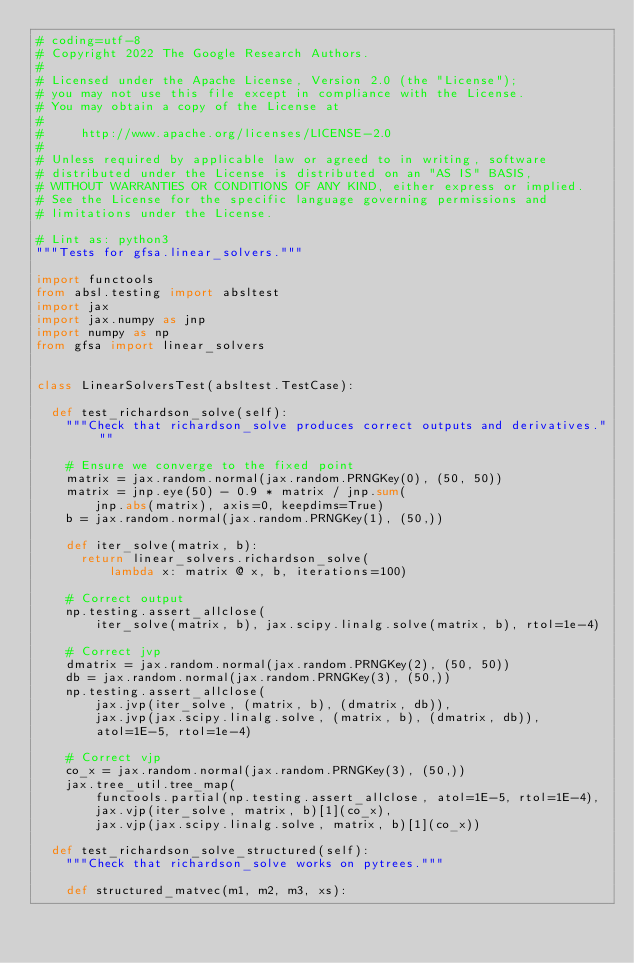Convert code to text. <code><loc_0><loc_0><loc_500><loc_500><_Python_># coding=utf-8
# Copyright 2022 The Google Research Authors.
#
# Licensed under the Apache License, Version 2.0 (the "License");
# you may not use this file except in compliance with the License.
# You may obtain a copy of the License at
#
#     http://www.apache.org/licenses/LICENSE-2.0
#
# Unless required by applicable law or agreed to in writing, software
# distributed under the License is distributed on an "AS IS" BASIS,
# WITHOUT WARRANTIES OR CONDITIONS OF ANY KIND, either express or implied.
# See the License for the specific language governing permissions and
# limitations under the License.

# Lint as: python3
"""Tests for gfsa.linear_solvers."""

import functools
from absl.testing import absltest
import jax
import jax.numpy as jnp
import numpy as np
from gfsa import linear_solvers


class LinearSolversTest(absltest.TestCase):

  def test_richardson_solve(self):
    """Check that richardson_solve produces correct outputs and derivatives."""

    # Ensure we converge to the fixed point
    matrix = jax.random.normal(jax.random.PRNGKey(0), (50, 50))
    matrix = jnp.eye(50) - 0.9 * matrix / jnp.sum(
        jnp.abs(matrix), axis=0, keepdims=True)
    b = jax.random.normal(jax.random.PRNGKey(1), (50,))

    def iter_solve(matrix, b):
      return linear_solvers.richardson_solve(
          lambda x: matrix @ x, b, iterations=100)

    # Correct output
    np.testing.assert_allclose(
        iter_solve(matrix, b), jax.scipy.linalg.solve(matrix, b), rtol=1e-4)

    # Correct jvp
    dmatrix = jax.random.normal(jax.random.PRNGKey(2), (50, 50))
    db = jax.random.normal(jax.random.PRNGKey(3), (50,))
    np.testing.assert_allclose(
        jax.jvp(iter_solve, (matrix, b), (dmatrix, db)),
        jax.jvp(jax.scipy.linalg.solve, (matrix, b), (dmatrix, db)),
        atol=1E-5, rtol=1e-4)

    # Correct vjp
    co_x = jax.random.normal(jax.random.PRNGKey(3), (50,))
    jax.tree_util.tree_map(
        functools.partial(np.testing.assert_allclose, atol=1E-5, rtol=1E-4),
        jax.vjp(iter_solve, matrix, b)[1](co_x),
        jax.vjp(jax.scipy.linalg.solve, matrix, b)[1](co_x))

  def test_richardson_solve_structured(self):
    """Check that richardson_solve works on pytrees."""

    def structured_matvec(m1, m2, m3, xs):</code> 